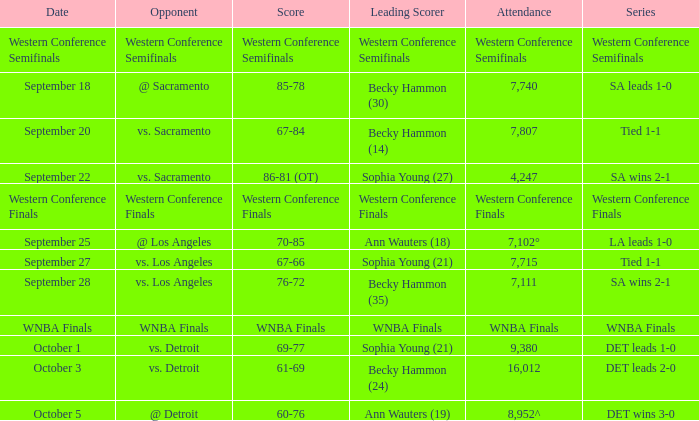Who is the opponent of the game with a tied 1-1 series and becky hammon (14) as the leading scorer? Vs. sacramento. 